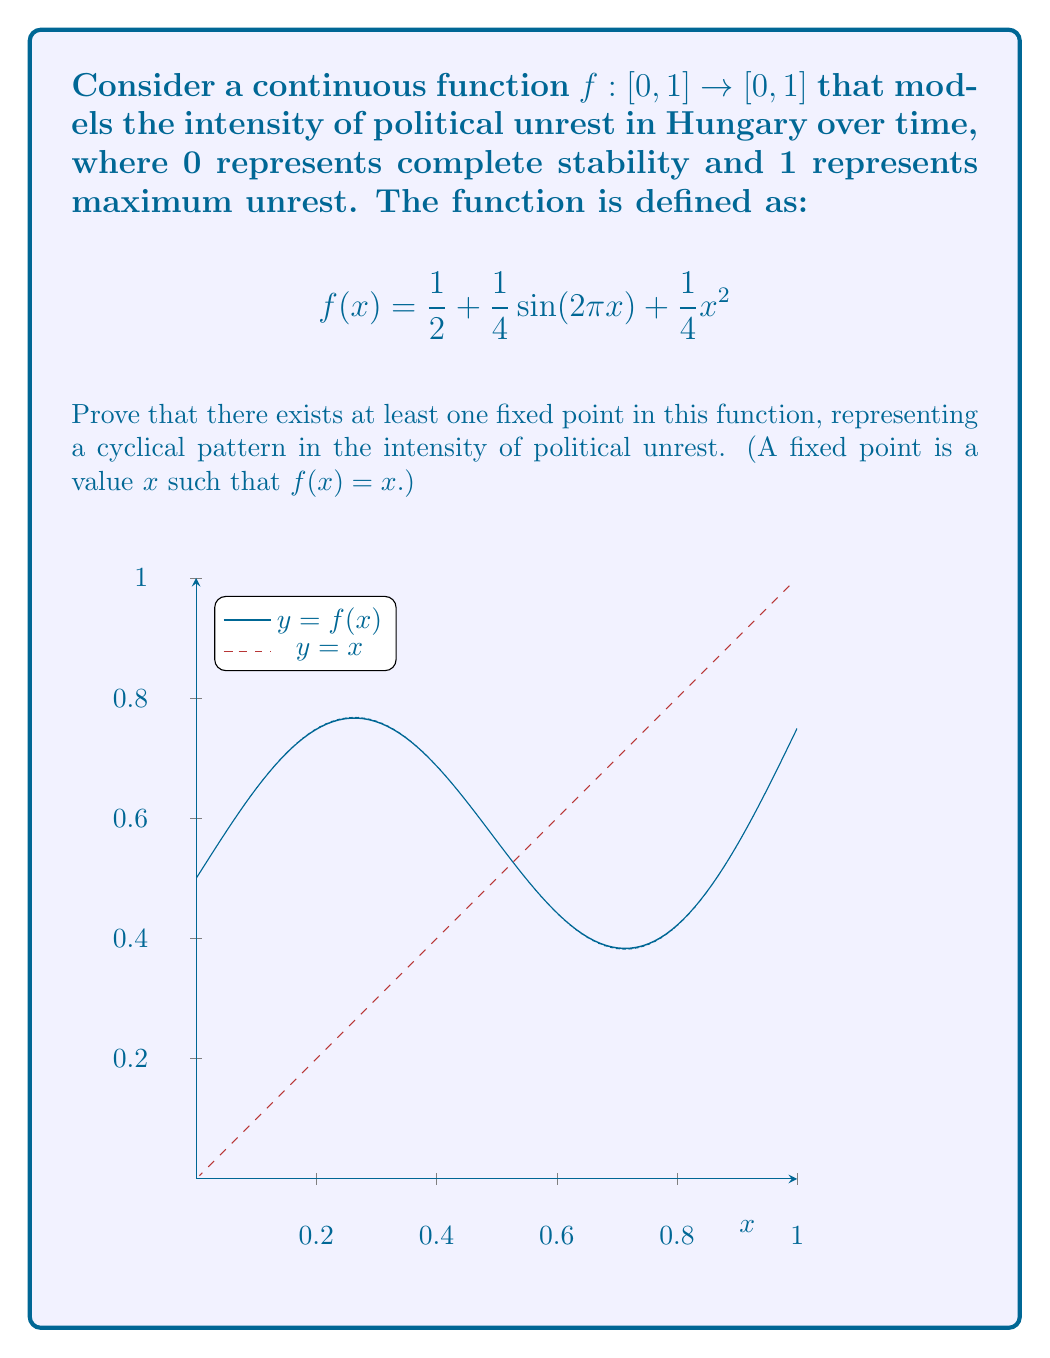What is the answer to this math problem? To prove the existence of a fixed point, we will use the Intermediate Value Theorem (IVT). The steps are as follows:

1) First, we need to show that $f$ is continuous on $[0,1]$. This is true because $f$ is a sum of continuous functions (polynomial, trigonometric) on a closed interval.

2) Define a new function $g(x) = f(x) - x$. A fixed point of $f$ occurs when $g(x) = 0$.

3) Let's evaluate $g$ at the endpoints of the interval:

   At $x = 0$: $g(0) = f(0) - 0 = \frac{1}{2} + 0 + 0 - 0 = \frac{1}{2} > 0$

   At $x = 1$: $g(1) = f(1) - 1 = \frac{1}{2} + 0 + \frac{1}{4} - 1 = -\frac{1}{4} < 0$

4) Since $g$ is continuous (as it's the difference of two continuous functions) and changes sign from positive to negative over the interval $[0,1]$, by the IVT, there must exist a point $c \in (0,1)$ such that $g(c) = 0$.

5) At this point $c$, we have $g(c) = f(c) - c = 0$, which means $f(c) = c$.

Therefore, we have proved that there exists at least one fixed point in the function $f$ on the interval $[0,1]$.
Answer: A fixed point exists by the Intermediate Value Theorem. 